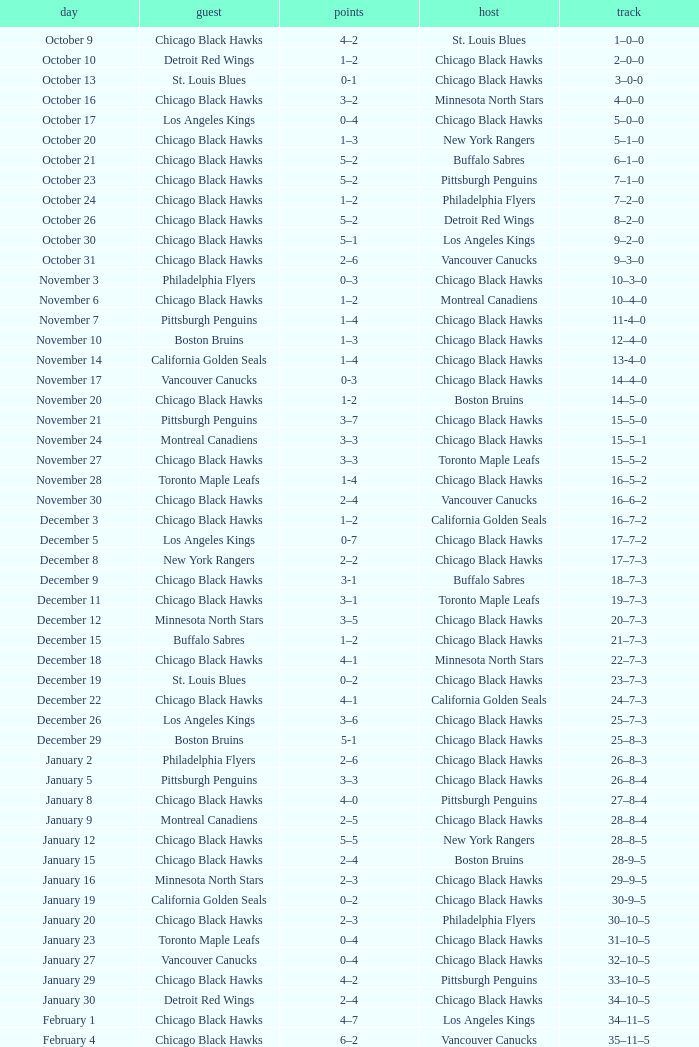What is the document of the february 26 date? 39–16–7. 